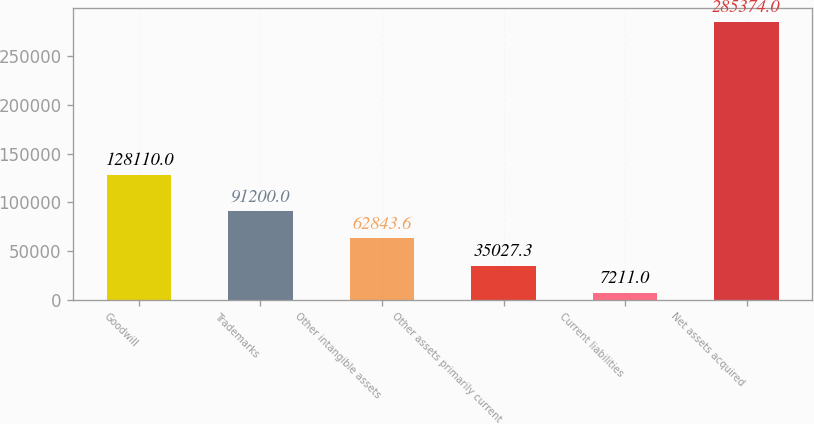Convert chart. <chart><loc_0><loc_0><loc_500><loc_500><bar_chart><fcel>Goodwill<fcel>Trademarks<fcel>Other intangible assets<fcel>Other assets primarily current<fcel>Current liabilities<fcel>Net assets acquired<nl><fcel>128110<fcel>91200<fcel>62843.6<fcel>35027.3<fcel>7211<fcel>285374<nl></chart> 